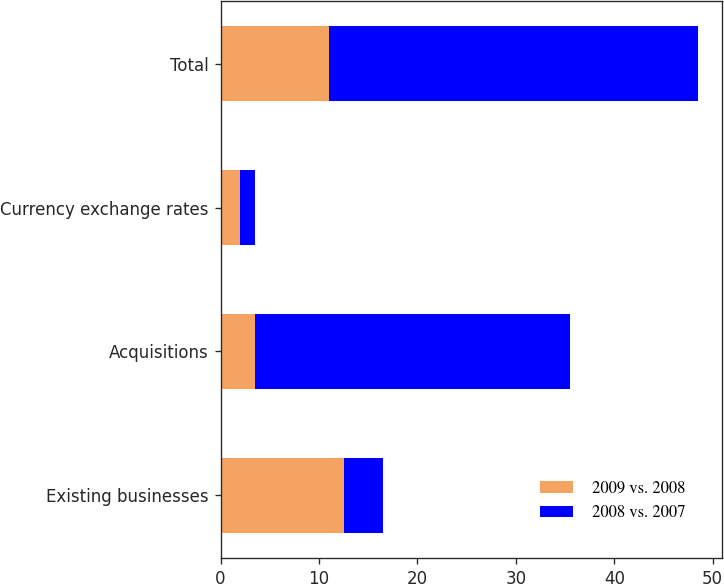<chart> <loc_0><loc_0><loc_500><loc_500><stacked_bar_chart><ecel><fcel>Existing businesses<fcel>Acquisitions<fcel>Currency exchange rates<fcel>Total<nl><fcel>2009 vs. 2008<fcel>12.5<fcel>3.5<fcel>2<fcel>11<nl><fcel>2008 vs. 2007<fcel>4<fcel>32<fcel>1.5<fcel>37.5<nl></chart> 